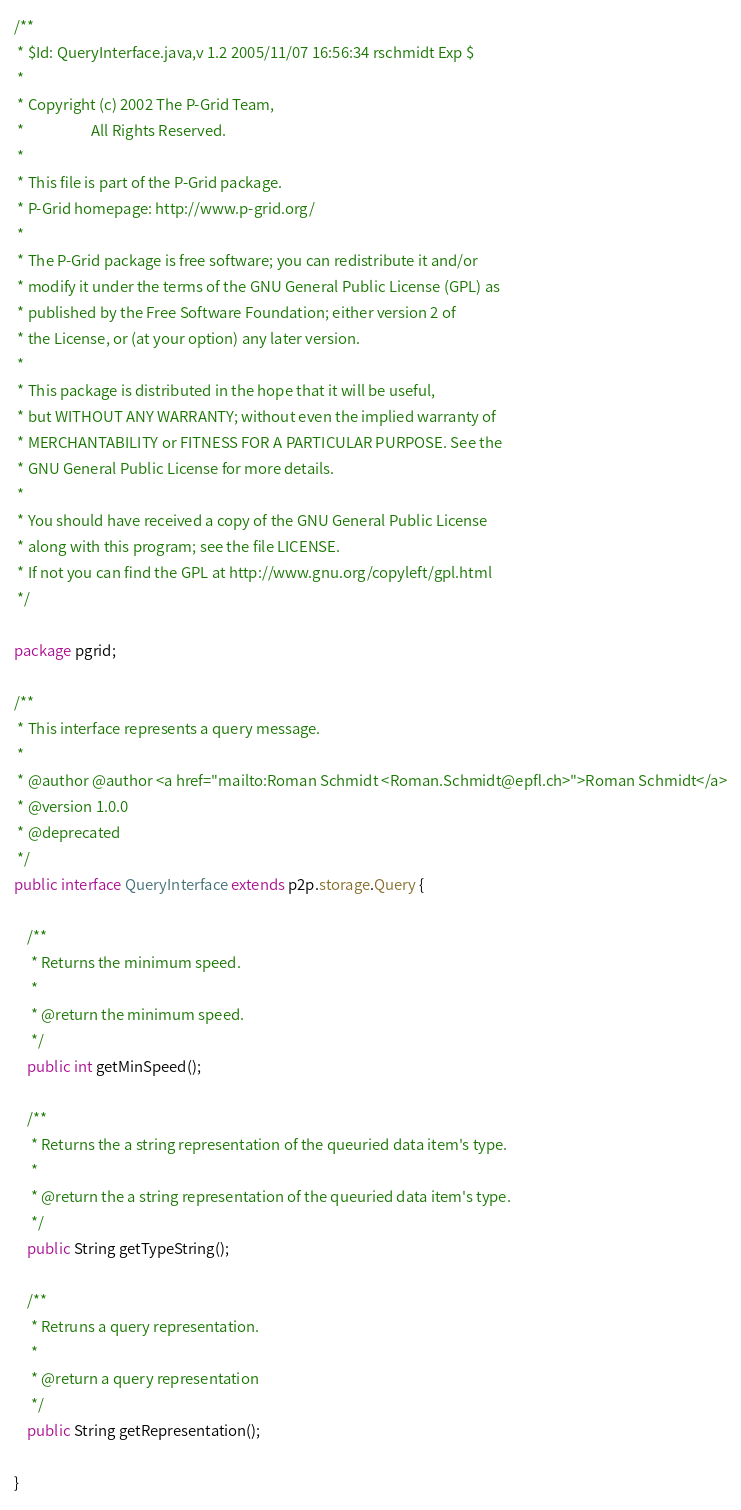Convert code to text. <code><loc_0><loc_0><loc_500><loc_500><_Java_>/**
 * $Id: QueryInterface.java,v 1.2 2005/11/07 16:56:34 rschmidt Exp $
 *
 * Copyright (c) 2002 The P-Grid Team,
 *                    All Rights Reserved.
 *
 * This file is part of the P-Grid package.
 * P-Grid homepage: http://www.p-grid.org/
 *
 * The P-Grid package is free software; you can redistribute it and/or
 * modify it under the terms of the GNU General Public License (GPL) as
 * published by the Free Software Foundation; either version 2 of
 * the License, or (at your option) any later version.
 *
 * This package is distributed in the hope that it will be useful,
 * but WITHOUT ANY WARRANTY; without even the implied warranty of
 * MERCHANTABILITY or FITNESS FOR A PARTICULAR PURPOSE. See the
 * GNU General Public License for more details.
 *
 * You should have received a copy of the GNU General Public License
 * along with this program; see the file LICENSE.
 * If not you can find the GPL at http://www.gnu.org/copyleft/gpl.html
 */

package pgrid;

/**
 * This interface represents a query message.
 *
 * @author @author <a href="mailto:Roman Schmidt <Roman.Schmidt@epfl.ch>">Roman Schmidt</a>
 * @version 1.0.0
 * @deprecated
 */
public interface QueryInterface extends p2p.storage.Query {

	/**
	 * Returns the minimum speed.
	 *
	 * @return the minimum speed.
	 */
	public int getMinSpeed();

	/**
	 * Returns the a string representation of the queuried data item's type.
	 *
	 * @return the a string representation of the queuried data item's type.
	 */
	public String getTypeString();

	/**
	 * Retruns a query representation.
	 *
	 * @return a query representation
	 */
	public String getRepresentation();

}
</code> 